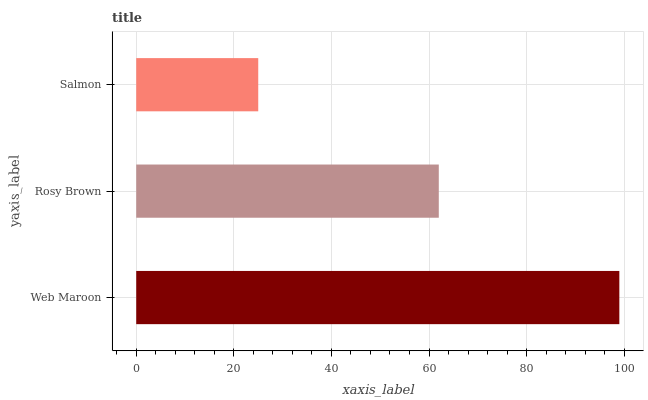Is Salmon the minimum?
Answer yes or no. Yes. Is Web Maroon the maximum?
Answer yes or no. Yes. Is Rosy Brown the minimum?
Answer yes or no. No. Is Rosy Brown the maximum?
Answer yes or no. No. Is Web Maroon greater than Rosy Brown?
Answer yes or no. Yes. Is Rosy Brown less than Web Maroon?
Answer yes or no. Yes. Is Rosy Brown greater than Web Maroon?
Answer yes or no. No. Is Web Maroon less than Rosy Brown?
Answer yes or no. No. Is Rosy Brown the high median?
Answer yes or no. Yes. Is Rosy Brown the low median?
Answer yes or no. Yes. Is Web Maroon the high median?
Answer yes or no. No. Is Web Maroon the low median?
Answer yes or no. No. 